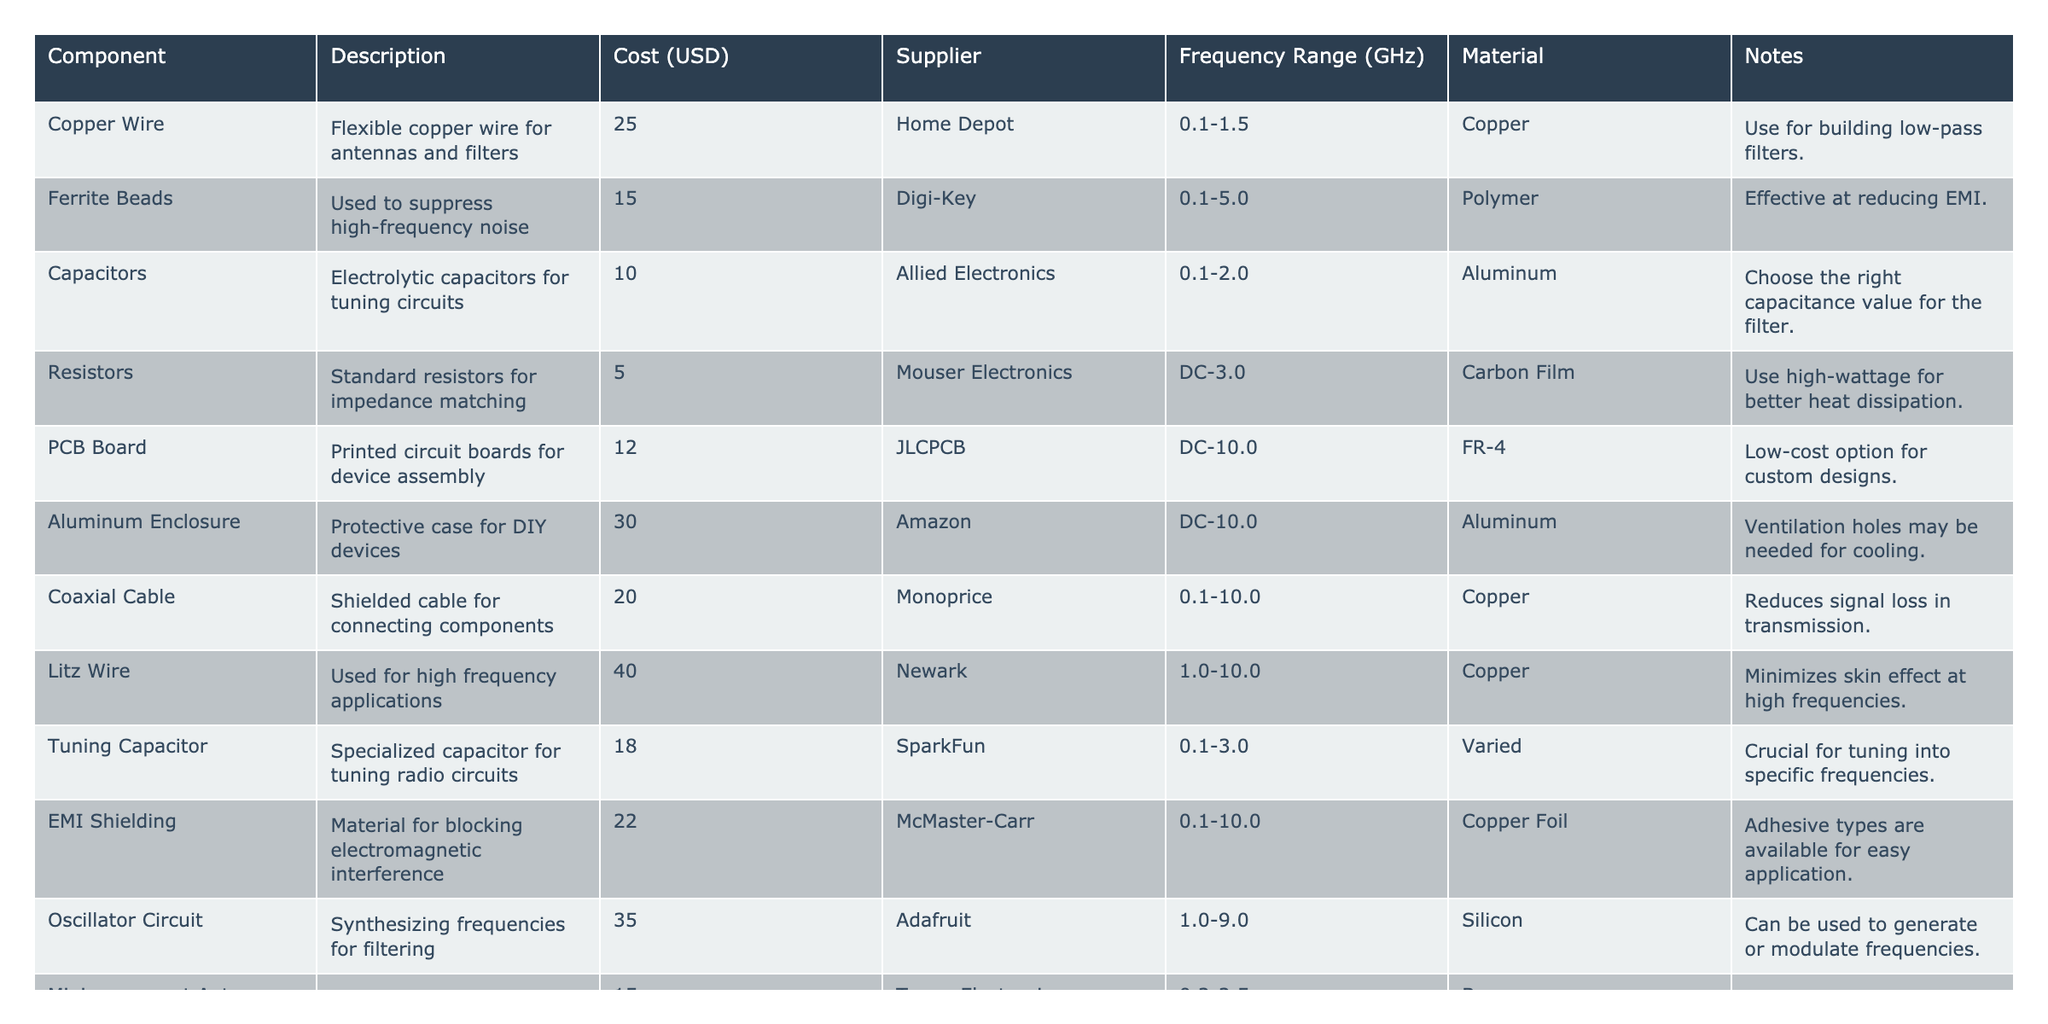What is the total cost of all components listed in the table? To find the total cost, we add the costs of all the components: 25 + 15 + 10 + 5 + 12 + 30 + 20 + 40 + 18 + 22 + 35 + 15 + 5 + 35 =  262 USD.
Answer: 262 USD Which component has the highest cost? Looking through the list, the component with the highest cost is the Litz Wire at 40 USD.
Answer: Litz Wire Is the Coaxial Cable more expensive than the Ferrite Beads? The Coaxial Cable costs 20 USD while the Ferrite Beads cost 15 USD. Since 20 is greater than 15, the statement is true.
Answer: Yes What is the average cost of the components? There are 14 components. Adding their costs gives 262 USD. The average cost is 262 / 14 ≈ 18.71 USD.
Answer: Approximately 18.71 USD Which supplier provides the Aluminum Enclosure? The Aluminum Enclosure can be found at Amazon according to the table.
Answer: Amazon Are there any components made of Copper? Checking the table, we find several components including Copper Wire, Coaxial Cable, and EMI Shielding which all use Copper. Hence, the answer is yes.
Answer: Yes What is the cost difference between the Oscillator Circuit and the Capacitors? The Oscillator Circuit costs 35 USD and the Capacitors cost 10 USD. The cost difference is 35 - 10 = 25 USD.
Answer: 25 USD How many components are designed for a frequency range above 5 GHz? The components that have a frequency range above 5 GHz include the Litz Wire, Oscillator Circuit, and Tuning Capacitor, totaling 3 components.
Answer: 3 components Is the Tuning Capacitor cheaper than the Aluminum Enclosure? The Tuning Capacitor costs 18 USD while the Aluminum Enclosure costs 30 USD. Since 18 is less than 30, the statement is true.
Answer: Yes Which component is designed for impedance matching? The Resistors are identified in the table as being used for impedance matching.
Answer: Resistors 